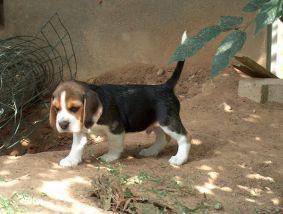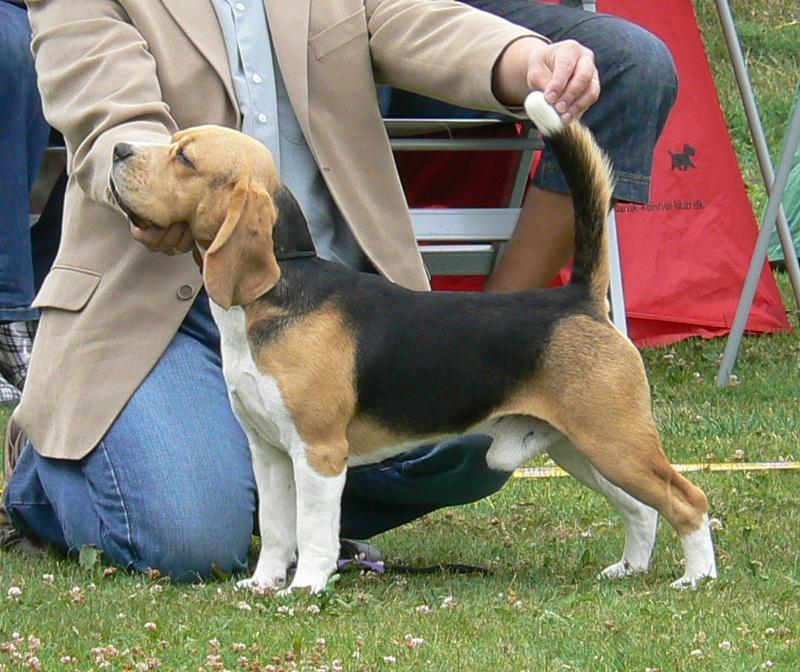The first image is the image on the left, the second image is the image on the right. Examine the images to the left and right. Is the description "A human is touching a dogs tail in the right image." accurate? Answer yes or no. Yes. The first image is the image on the left, the second image is the image on the right. For the images shown, is this caption "A person is behind a standing beagle, holding the base of its tail upward with one hand and propping its chin with the other." true? Answer yes or no. Yes. 